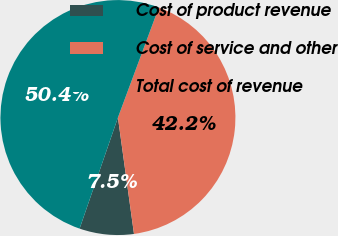Convert chart. <chart><loc_0><loc_0><loc_500><loc_500><pie_chart><fcel>Cost of product revenue<fcel>Cost of service and other<fcel>Total cost of revenue<nl><fcel>7.47%<fcel>42.15%<fcel>50.37%<nl></chart> 